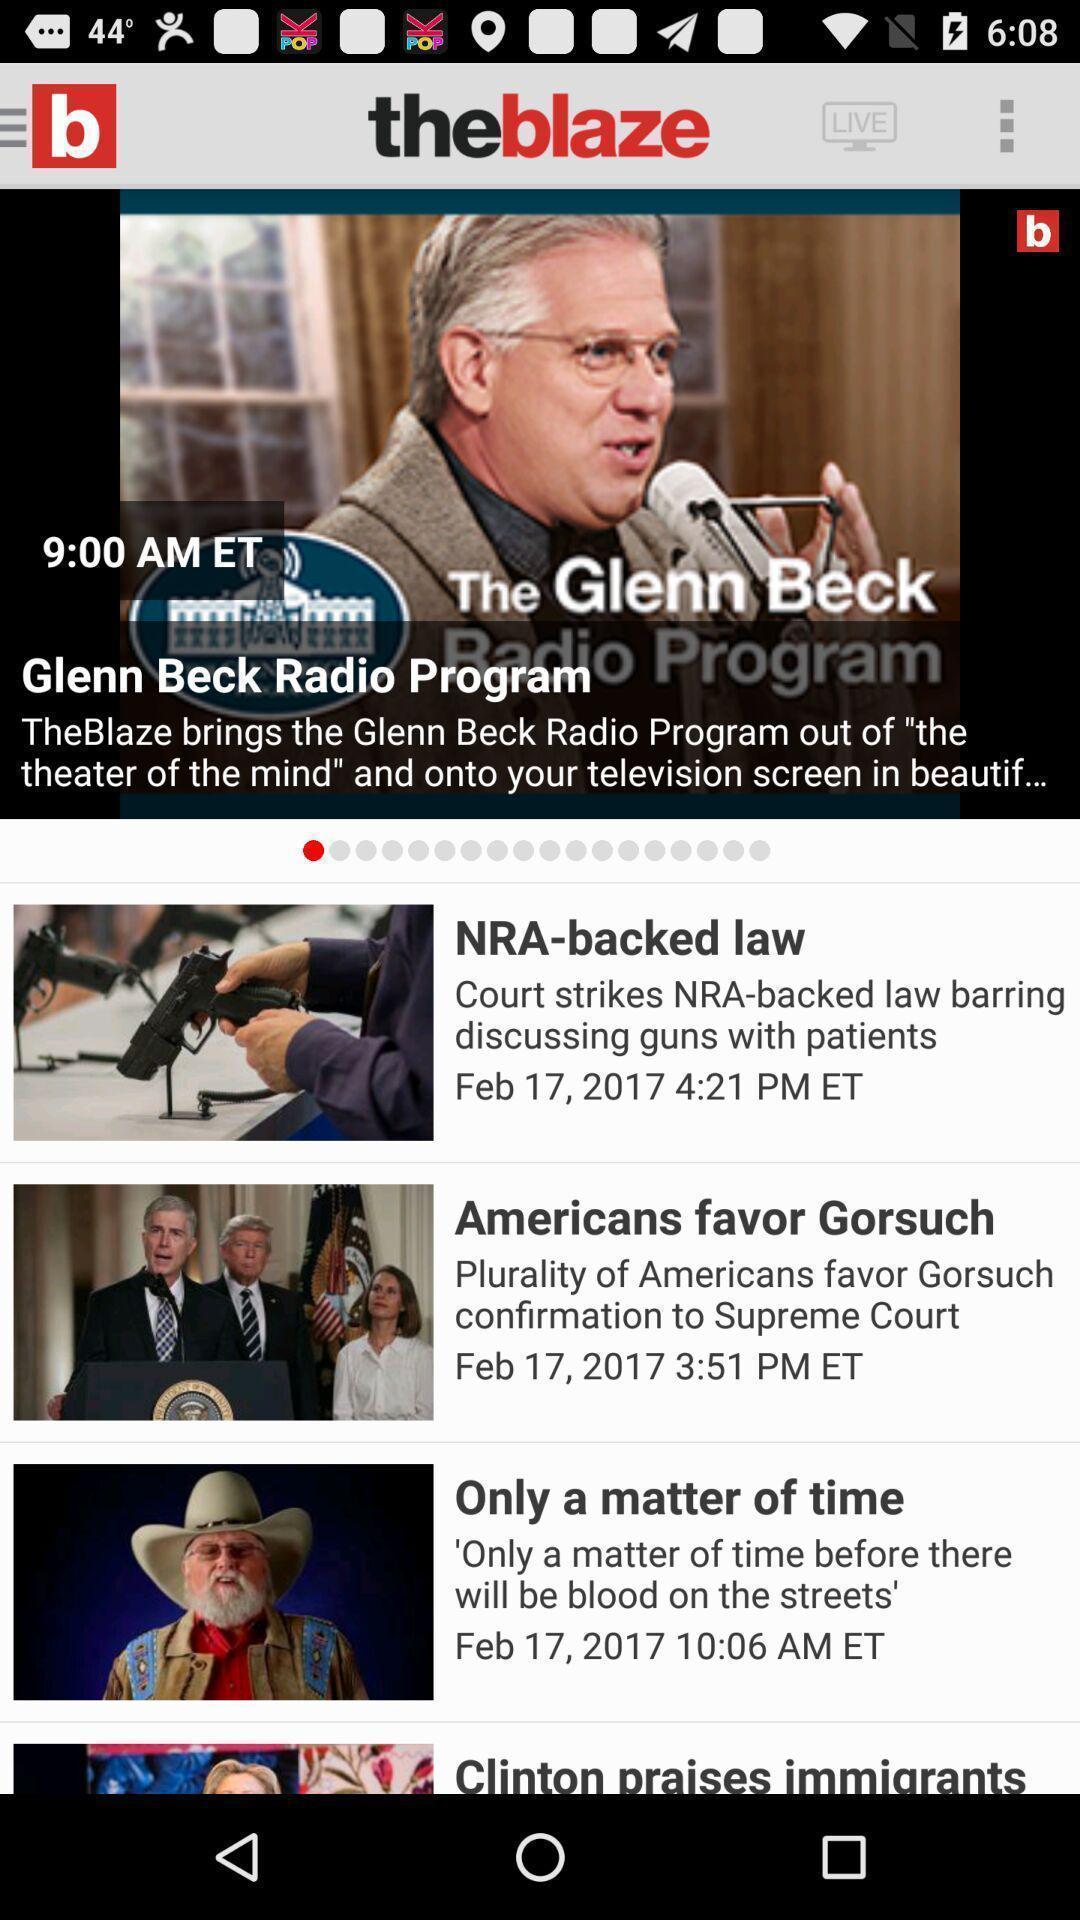What can you discern from this picture? Page showing live content. 